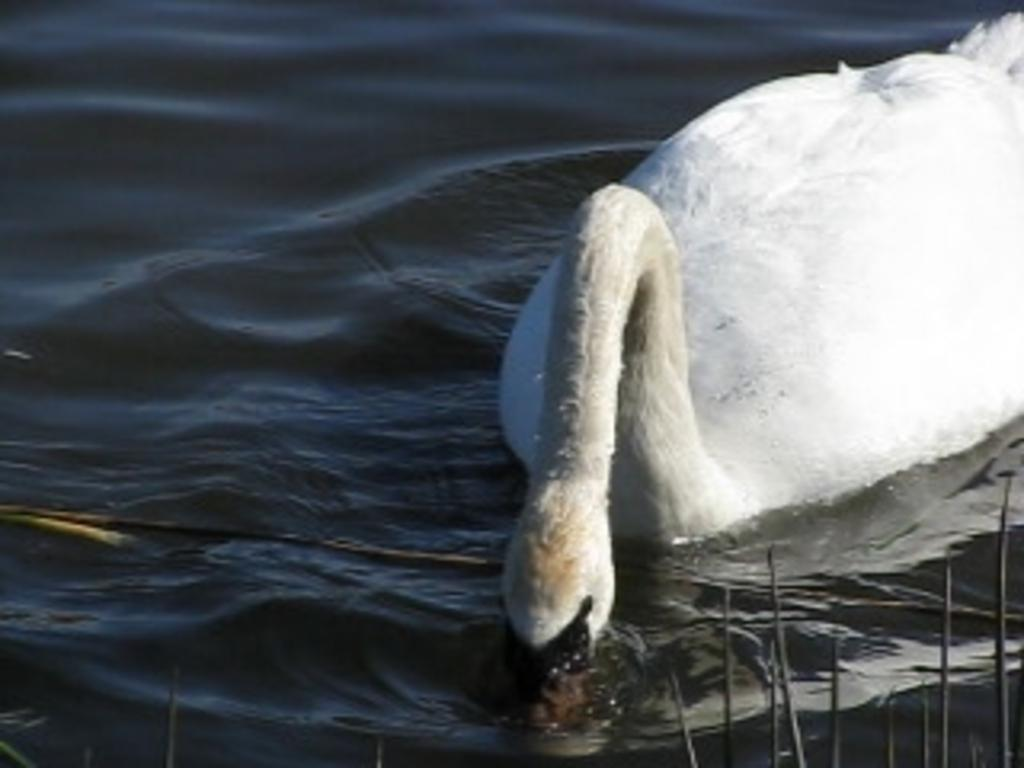What is the main subject of the image? There is a bird on the water in the image. Can you describe any other elements in the image? Yes, there are objects in the image. What type of afterthought is the bird experiencing while on the water? There is no indication of any afterthought in the image, as it simply shows a bird on the water. Can you see any gloves in the image? No, there are no gloves present in the image. 